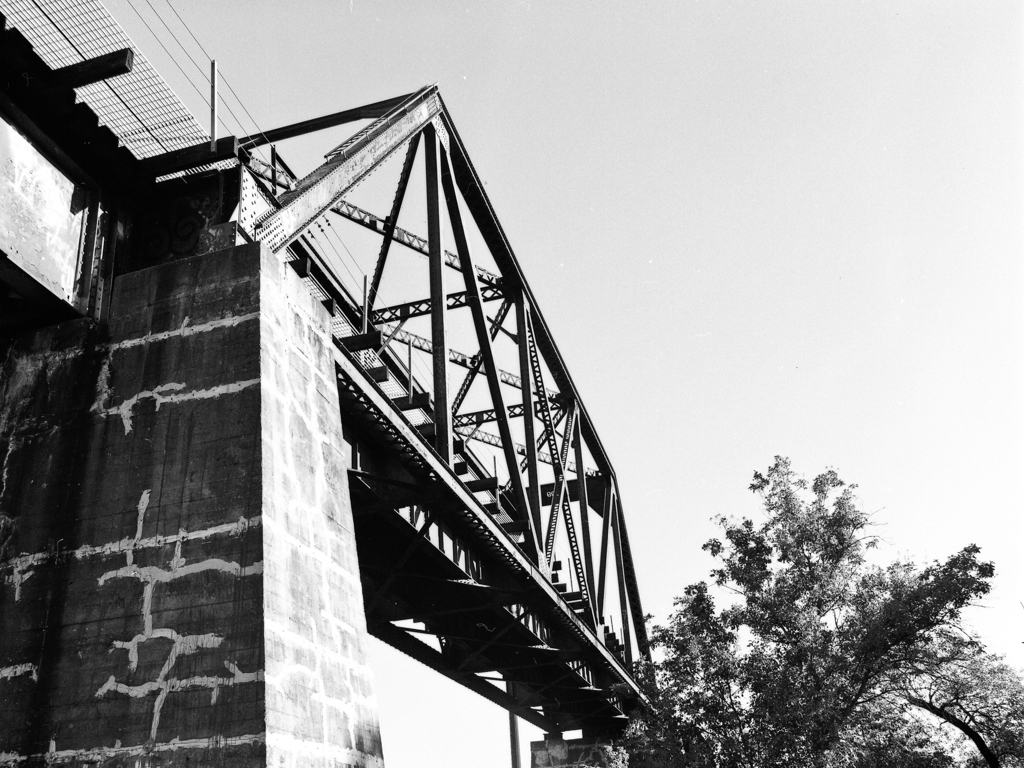Is the quality of this image acceptable? The image appears to be of high quality with clear details and good contrast, but without knowing the specific criteria for 'acceptable,' it's difficult to provide a definitive answer. Factors such as intended use, desired resolution, and artistic effect all influence the acceptability of image quality. 